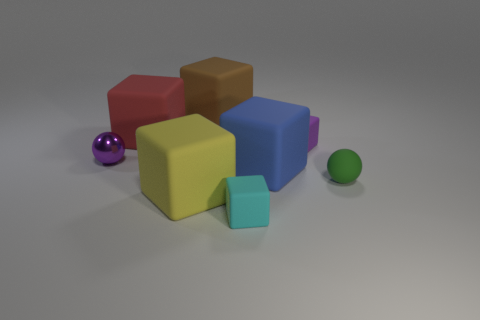The cyan thing that is the same size as the purple block is what shape?
Offer a terse response. Cube. Is there another thing that has the same shape as the tiny green matte thing?
Make the answer very short. Yes. Does the sphere that is on the left side of the large red cube have the same color as the small rubber block that is behind the yellow matte block?
Offer a terse response. Yes. There is a big yellow matte thing; are there any large brown matte blocks to the right of it?
Offer a terse response. Yes. There is a small thing that is behind the tiny green matte thing and left of the blue cube; what is its material?
Make the answer very short. Metal. Are the thing right of the tiny purple matte block and the brown cube made of the same material?
Offer a very short reply. Yes. What is the material of the purple sphere?
Your answer should be compact. Metal. What is the size of the yellow cube that is in front of the purple metal object?
Give a very brief answer. Large. Is there any other thing that is the same color as the small matte ball?
Ensure brevity in your answer.  No. Is there a cube behind the small object behind the small purple thing to the left of the large blue rubber block?
Offer a terse response. Yes. 